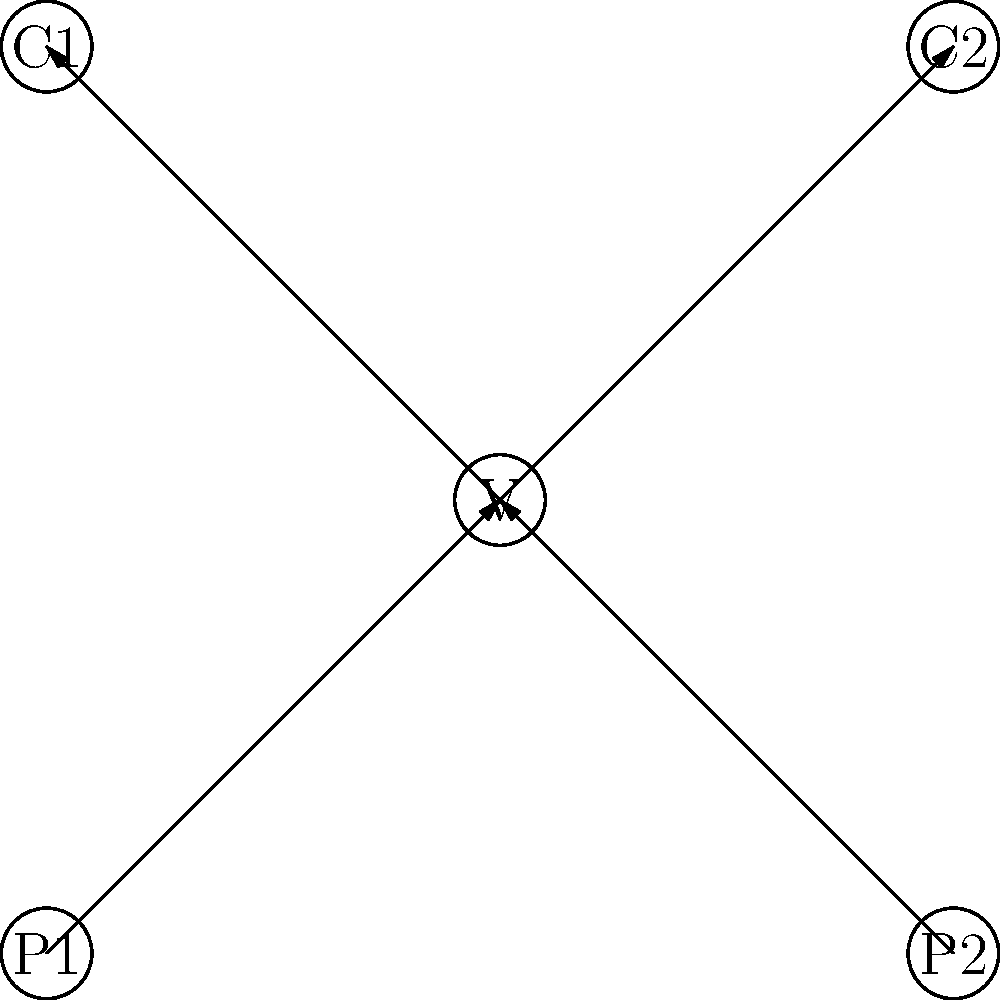In a hospice setting, you're tasked with modeling patient-caregiver relationships using a directed graph. The graph shows two patients (P1 and P2), two caregivers (C1 and C2), and a volunteer (V). Arrows represent care relationships, with all care flowing through the volunteer. How many different paths exist from patients to caregivers in this model? Let's approach this step-by-step:

1) First, we need to identify the possible paths in the graph:
   - P1 → V → C1
   - P1 → V → C2
   - P2 → V → C1
   - P2 → V → C2

2) To count the paths:
   - From P1, there are 2 paths (to C1 and C2)
   - From P2, there are 2 paths (to C1 and C2)

3) To get the total number of paths, we sum these:
   2 + 2 = 4

Therefore, there are 4 different paths from patients to caregivers in this model.

This graph structure ensures that all care interactions are coordinated through the volunteer, which might represent a realistic scenario in a hospice setting where volunteers play a crucial role in facilitating patient care.
Answer: 4 paths 